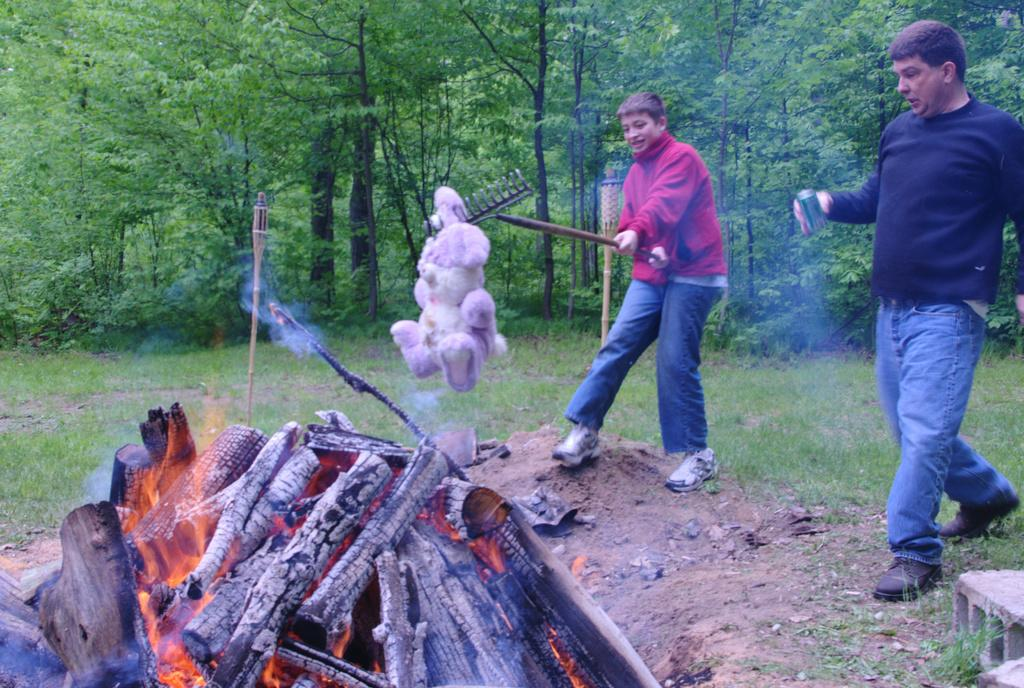What is the main feature of the image? There is fire in the image. What are the two persons in the image doing? They are holding objects in the image. What can be seen supporting the objects in the image? There are poles in the image. What type of lighting is present in the image? There are lights in the image. What type of vegetation is visible in the image? There is grass in the image. What can be seen in the background of the image? There are trees in the background of the image. What type of pipe can be seen being played by a group of musicians in the image? There is no pipe or group of musicians present in the image. 